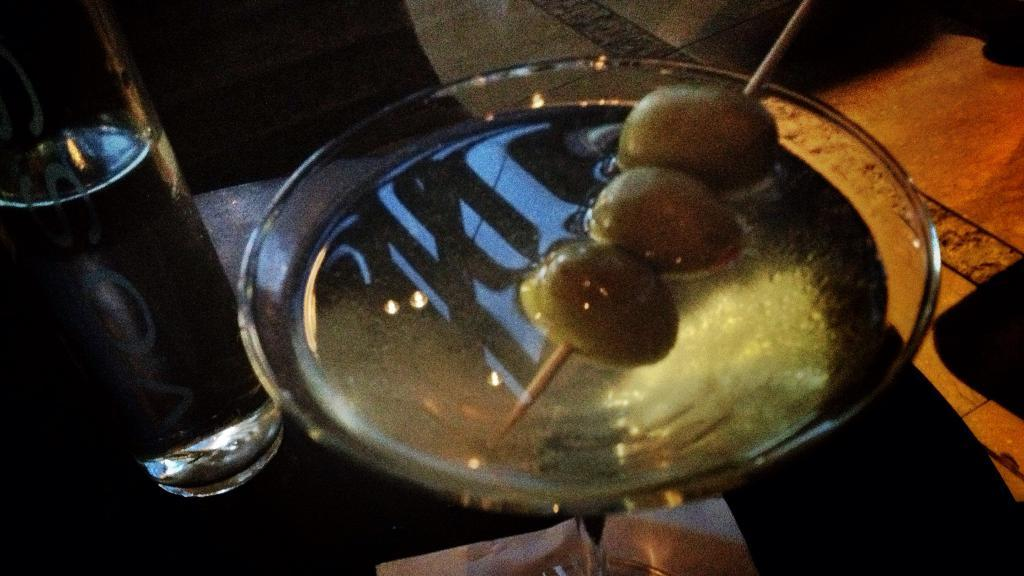What is in the bowl that is visible in the image? There is a bowl with soup in the image. Besides the soup, what other items can be seen in the image? There are pickles in the image. How are the pickles arranged or prepared in the image? The pickles are pricked with a toothpick in the image. What is located on a table in the image? There is a water bottle on a table in the image. What type of mint can be seen growing in the image? There is no mint plant or leaves present in the image. 